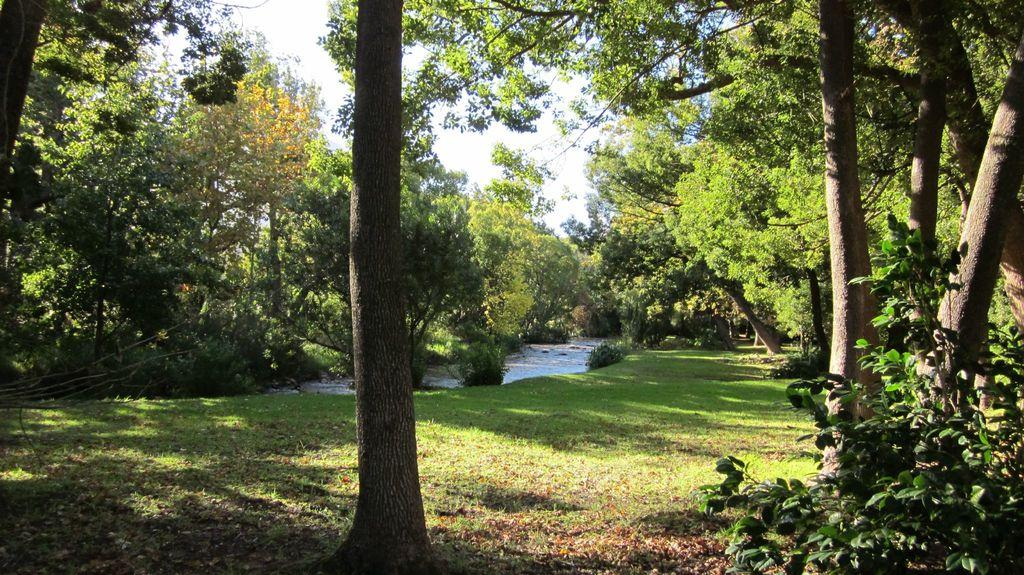What type of vegetation is present in the image? There are trees in the image. What is at the bottom of the image? There is grass at the bottom of the image. What else can be seen in the image besides trees and grass? There is water visible in the image. What is visible at the top of the image? The sky is visible at the top of the image. Where is the doctor standing in the image? There is no doctor present in the image. What type of bomb can be seen in the image? There is no bomb present in the image. 